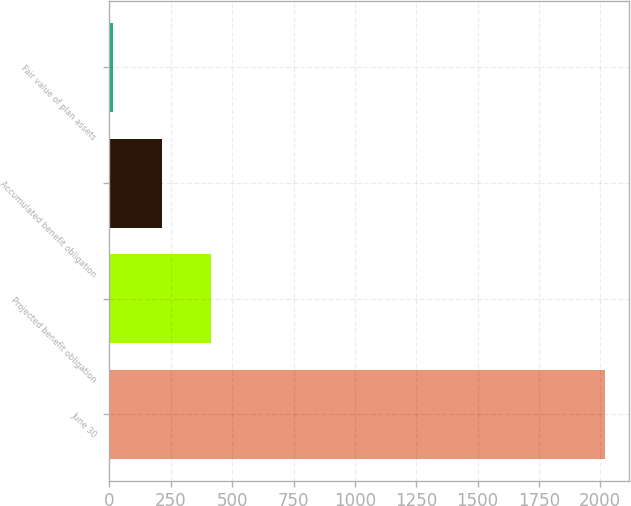Convert chart. <chart><loc_0><loc_0><loc_500><loc_500><bar_chart><fcel>June 30<fcel>Projected benefit obligation<fcel>Accumulated benefit obligation<fcel>Fair value of plan assets<nl><fcel>2018<fcel>414.24<fcel>213.77<fcel>13.3<nl></chart> 